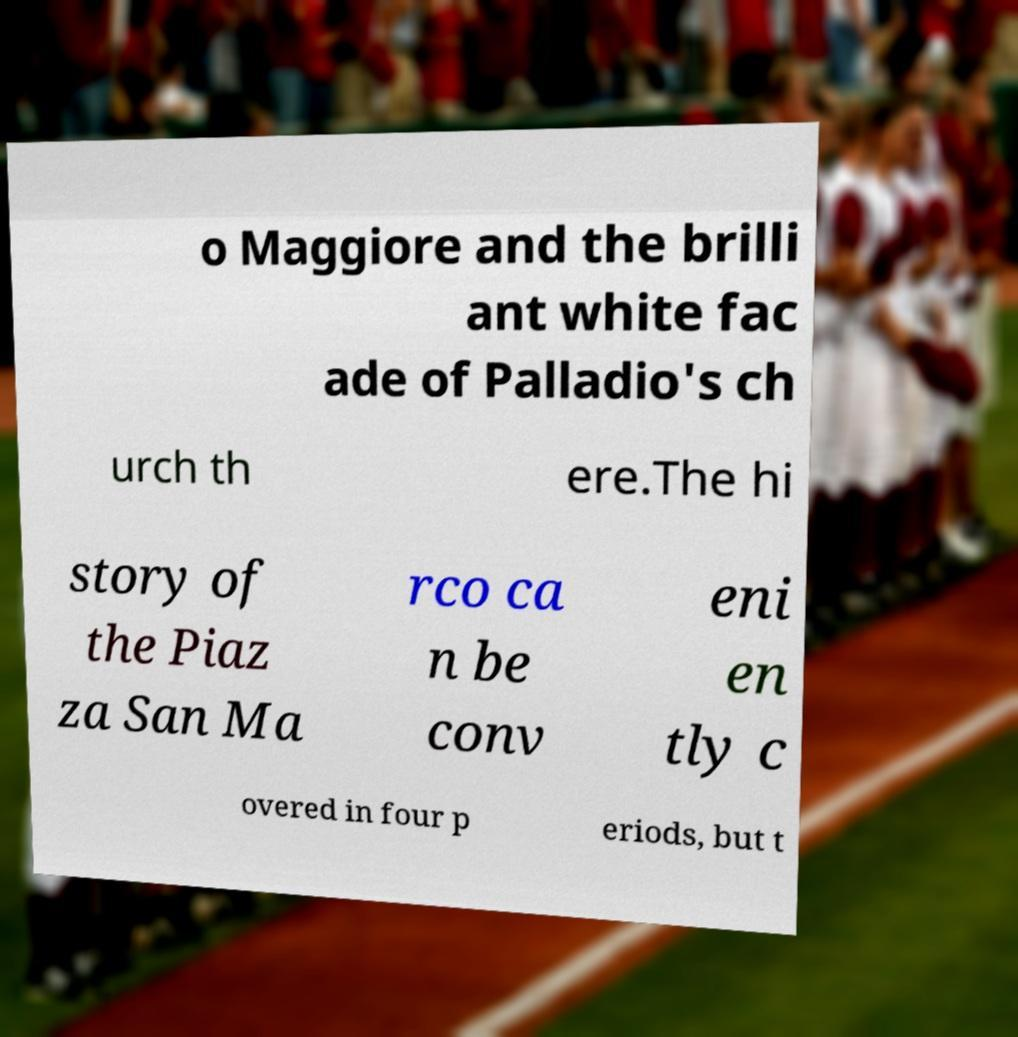Can you read and provide the text displayed in the image?This photo seems to have some interesting text. Can you extract and type it out for me? o Maggiore and the brilli ant white fac ade of Palladio's ch urch th ere.The hi story of the Piaz za San Ma rco ca n be conv eni en tly c overed in four p eriods, but t 